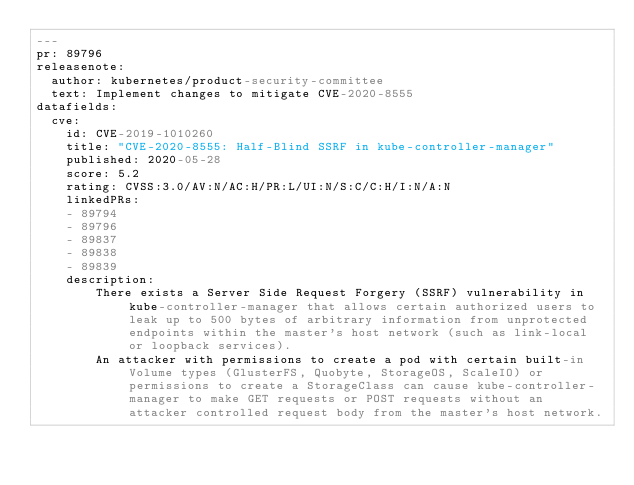<code> <loc_0><loc_0><loc_500><loc_500><_YAML_>---
pr: 89796 
releasenote:
  author: kubernetes/product-security-committee
  text: Implement changes to mitigate CVE-2020-8555
datafields:
  cve:
    id: CVE-2019-1010260
    title: "CVE-2020-8555: Half-Blind SSRF in kube-controller-manager"
    published: 2020-05-28
    score: 5.2
    rating: CVSS:3.0/AV:N/AC:H/PR:L/UI:N/S:C/C:H/I:N/A:N
    linkedPRs:
    - 89794
    - 89796
    - 89837
    - 89838
    - 89839
    description:
        There exists a Server Side Request Forgery (SSRF) vulnerability in kube-controller-manager that allows certain authorized users to leak up to 500 bytes of arbitrary information from unprotected endpoints within the master's host network (such as link-local or loopback services).
        An attacker with permissions to create a pod with certain built-in Volume types (GlusterFS, Quobyte, StorageOS, ScaleIO) or permissions to create a StorageClass can cause kube-controller-manager to make GET requests or POST requests without an attacker controlled request body from the master's host network.
</code> 